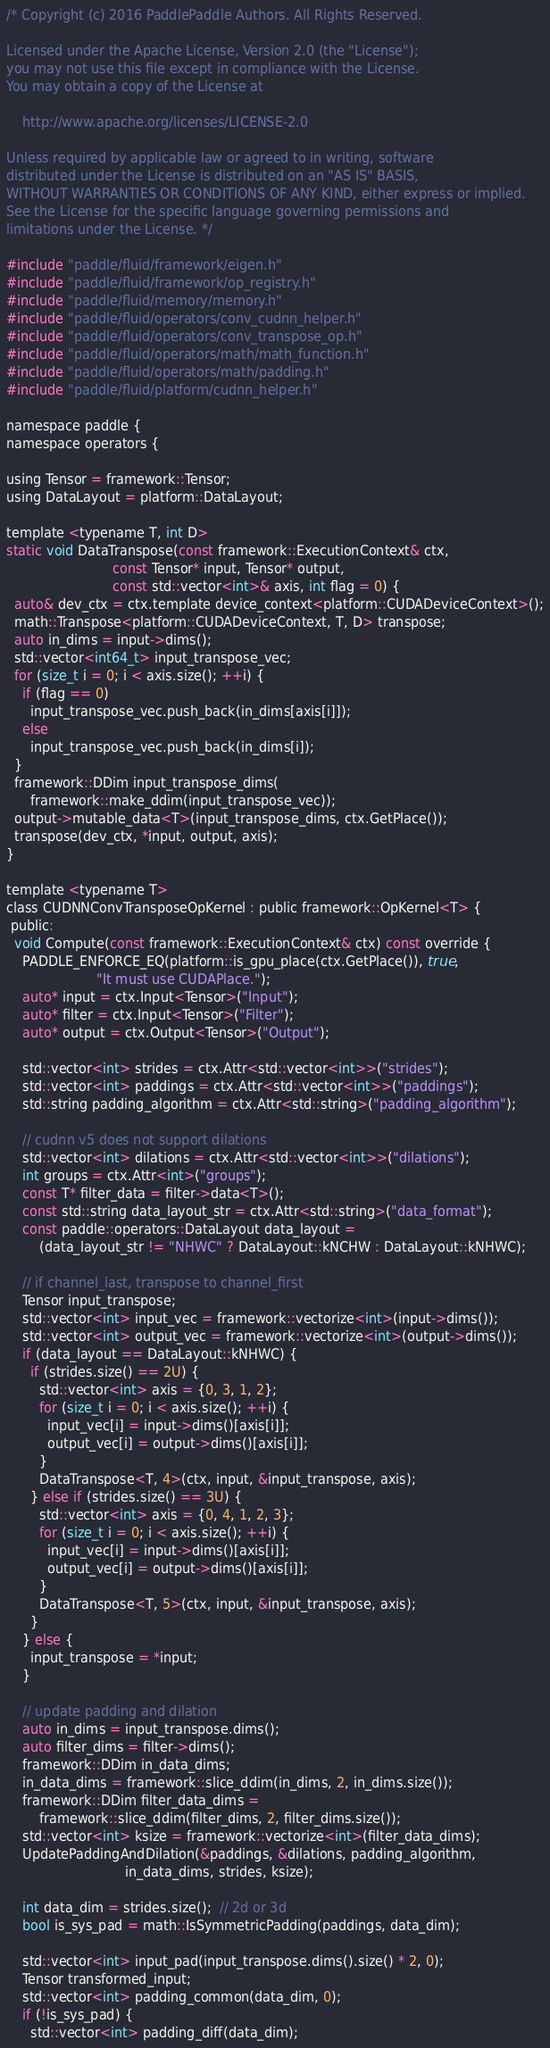<code> <loc_0><loc_0><loc_500><loc_500><_Cuda_>/* Copyright (c) 2016 PaddlePaddle Authors. All Rights Reserved.

Licensed under the Apache License, Version 2.0 (the "License");
you may not use this file except in compliance with the License.
You may obtain a copy of the License at

    http://www.apache.org/licenses/LICENSE-2.0

Unless required by applicable law or agreed to in writing, software
distributed under the License is distributed on an "AS IS" BASIS,
WITHOUT WARRANTIES OR CONDITIONS OF ANY KIND, either express or implied.
See the License for the specific language governing permissions and
limitations under the License. */

#include "paddle/fluid/framework/eigen.h"
#include "paddle/fluid/framework/op_registry.h"
#include "paddle/fluid/memory/memory.h"
#include "paddle/fluid/operators/conv_cudnn_helper.h"
#include "paddle/fluid/operators/conv_transpose_op.h"
#include "paddle/fluid/operators/math/math_function.h"
#include "paddle/fluid/operators/math/padding.h"
#include "paddle/fluid/platform/cudnn_helper.h"

namespace paddle {
namespace operators {

using Tensor = framework::Tensor;
using DataLayout = platform::DataLayout;

template <typename T, int D>
static void DataTranspose(const framework::ExecutionContext& ctx,
                          const Tensor* input, Tensor* output,
                          const std::vector<int>& axis, int flag = 0) {
  auto& dev_ctx = ctx.template device_context<platform::CUDADeviceContext>();
  math::Transpose<platform::CUDADeviceContext, T, D> transpose;
  auto in_dims = input->dims();
  std::vector<int64_t> input_transpose_vec;
  for (size_t i = 0; i < axis.size(); ++i) {
    if (flag == 0)
      input_transpose_vec.push_back(in_dims[axis[i]]);
    else
      input_transpose_vec.push_back(in_dims[i]);
  }
  framework::DDim input_transpose_dims(
      framework::make_ddim(input_transpose_vec));
  output->mutable_data<T>(input_transpose_dims, ctx.GetPlace());
  transpose(dev_ctx, *input, output, axis);
}

template <typename T>
class CUDNNConvTransposeOpKernel : public framework::OpKernel<T> {
 public:
  void Compute(const framework::ExecutionContext& ctx) const override {
    PADDLE_ENFORCE_EQ(platform::is_gpu_place(ctx.GetPlace()), true,
                      "It must use CUDAPlace.");
    auto* input = ctx.Input<Tensor>("Input");
    auto* filter = ctx.Input<Tensor>("Filter");
    auto* output = ctx.Output<Tensor>("Output");

    std::vector<int> strides = ctx.Attr<std::vector<int>>("strides");
    std::vector<int> paddings = ctx.Attr<std::vector<int>>("paddings");
    std::string padding_algorithm = ctx.Attr<std::string>("padding_algorithm");

    // cudnn v5 does not support dilations
    std::vector<int> dilations = ctx.Attr<std::vector<int>>("dilations");
    int groups = ctx.Attr<int>("groups");
    const T* filter_data = filter->data<T>();
    const std::string data_layout_str = ctx.Attr<std::string>("data_format");
    const paddle::operators::DataLayout data_layout =
        (data_layout_str != "NHWC" ? DataLayout::kNCHW : DataLayout::kNHWC);

    // if channel_last, transpose to channel_first
    Tensor input_transpose;
    std::vector<int> input_vec = framework::vectorize<int>(input->dims());
    std::vector<int> output_vec = framework::vectorize<int>(output->dims());
    if (data_layout == DataLayout::kNHWC) {
      if (strides.size() == 2U) {
        std::vector<int> axis = {0, 3, 1, 2};
        for (size_t i = 0; i < axis.size(); ++i) {
          input_vec[i] = input->dims()[axis[i]];
          output_vec[i] = output->dims()[axis[i]];
        }
        DataTranspose<T, 4>(ctx, input, &input_transpose, axis);
      } else if (strides.size() == 3U) {
        std::vector<int> axis = {0, 4, 1, 2, 3};
        for (size_t i = 0; i < axis.size(); ++i) {
          input_vec[i] = input->dims()[axis[i]];
          output_vec[i] = output->dims()[axis[i]];
        }
        DataTranspose<T, 5>(ctx, input, &input_transpose, axis);
      }
    } else {
      input_transpose = *input;
    }

    // update padding and dilation
    auto in_dims = input_transpose.dims();
    auto filter_dims = filter->dims();
    framework::DDim in_data_dims;
    in_data_dims = framework::slice_ddim(in_dims, 2, in_dims.size());
    framework::DDim filter_data_dims =
        framework::slice_ddim(filter_dims, 2, filter_dims.size());
    std::vector<int> ksize = framework::vectorize<int>(filter_data_dims);
    UpdatePaddingAndDilation(&paddings, &dilations, padding_algorithm,
                             in_data_dims, strides, ksize);

    int data_dim = strides.size();  // 2d or 3d
    bool is_sys_pad = math::IsSymmetricPadding(paddings, data_dim);

    std::vector<int> input_pad(input_transpose.dims().size() * 2, 0);
    Tensor transformed_input;
    std::vector<int> padding_common(data_dim, 0);
    if (!is_sys_pad) {
      std::vector<int> padding_diff(data_dim);</code> 